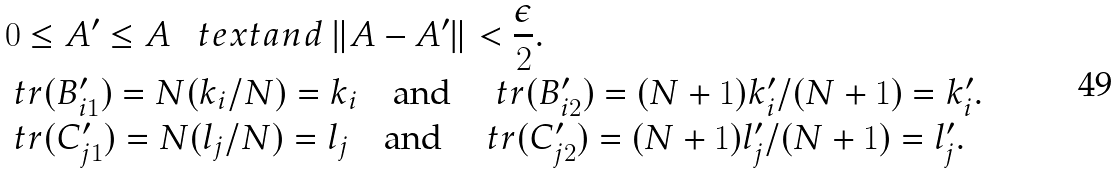Convert formula to latex. <formula><loc_0><loc_0><loc_500><loc_500>& 0 \leq A ^ { \prime } \leq A \ \ \ t e x t { a n d } \ \| A - A ^ { \prime } \| < \frac { \epsilon } { 2 } . \\ & \ t r ( B ^ { \prime } _ { i 1 } ) = N ( k _ { i } / N ) = k _ { i } \quad \text {and} \quad \ t r ( B ^ { \prime } _ { i 2 } ) = ( N + 1 ) k ^ { \prime } _ { i } / ( N + 1 ) = k ^ { \prime } _ { i } . \\ & \ t r ( C ^ { \prime } _ { j 1 } ) = N ( l _ { j } / N ) = l _ { j } \quad \text {and} \quad \ t r ( C ^ { \prime } _ { j 2 } ) = ( N + 1 ) l ^ { \prime } _ { j } / ( N + 1 ) = l ^ { \prime } _ { j } .</formula> 